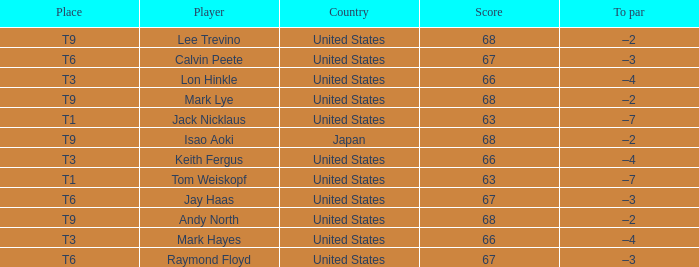What is the location, when the nation is "united states", and when the athlete is "lee trevino"? T9. 